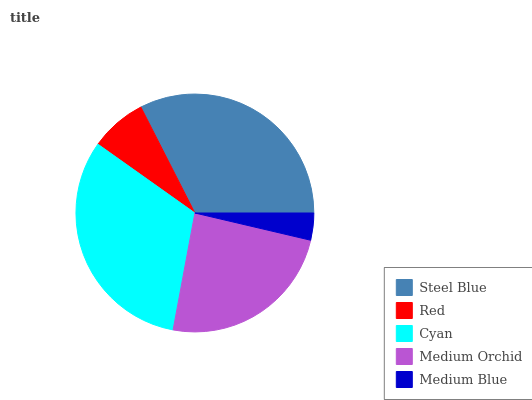Is Medium Blue the minimum?
Answer yes or no. Yes. Is Steel Blue the maximum?
Answer yes or no. Yes. Is Red the minimum?
Answer yes or no. No. Is Red the maximum?
Answer yes or no. No. Is Steel Blue greater than Red?
Answer yes or no. Yes. Is Red less than Steel Blue?
Answer yes or no. Yes. Is Red greater than Steel Blue?
Answer yes or no. No. Is Steel Blue less than Red?
Answer yes or no. No. Is Medium Orchid the high median?
Answer yes or no. Yes. Is Medium Orchid the low median?
Answer yes or no. Yes. Is Cyan the high median?
Answer yes or no. No. Is Red the low median?
Answer yes or no. No. 